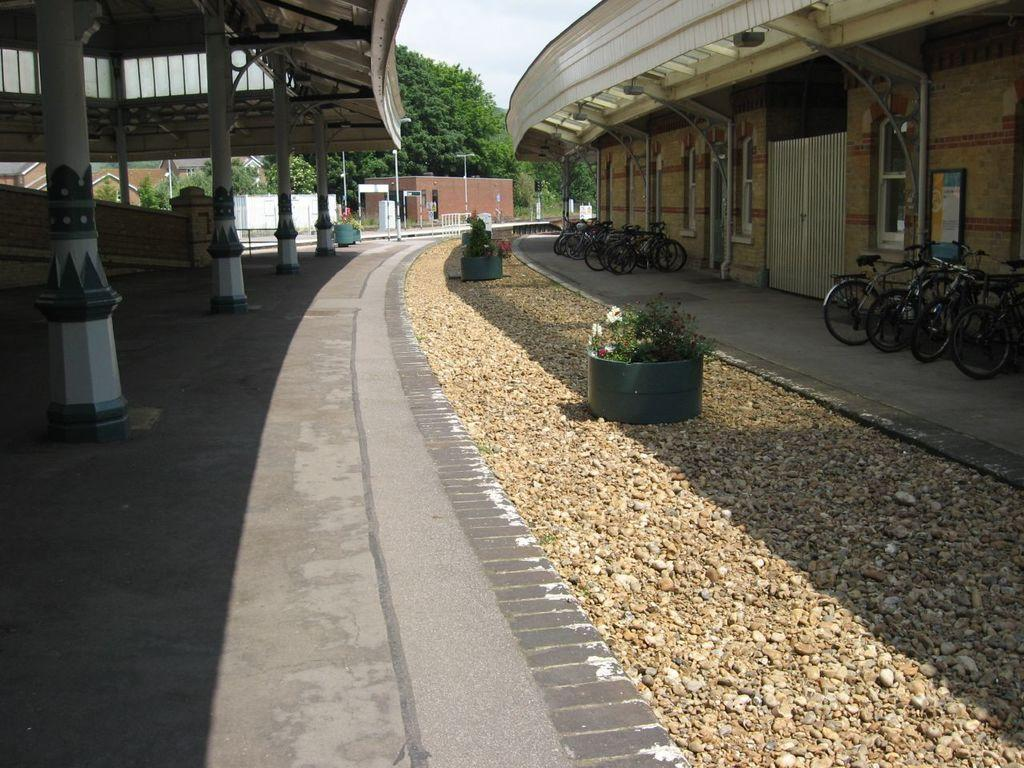What type of structures can be seen in the image? There are buildings in the image. What other elements are present in the image besides buildings? There are plants, stones, and bicycles visible in the image. What can be seen in the background of the image? In the background, there are trees, poles, and metal rods. What type of lunch is being served in the image? There is no lunch present in the image; it features buildings, plants, stones, bicycles, trees, poles, and metal rods. What color is the thread used to decorate the bicycles in the image? There is no thread present in the image, as the bicycles are not shown to be decorated. 